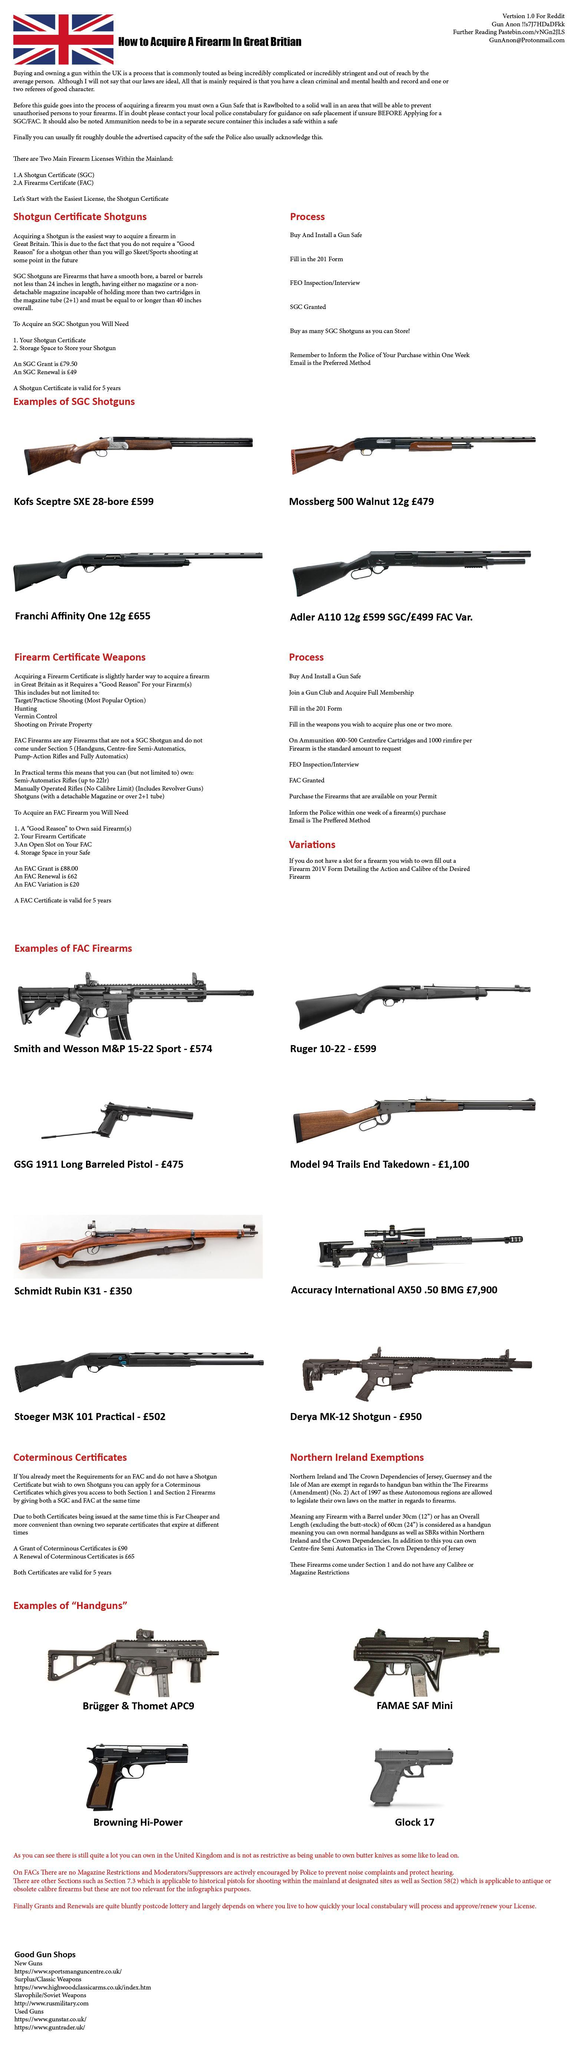Once received a Shortgun certificate, in how many years it will get expired?
Answer the question with a short phrase. 5 years Which are the major Firearm licenses available within UK? A shotgun certificate (SGC), A Firearms Certificate (FAC) 